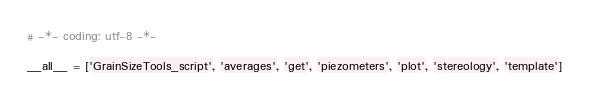<code> <loc_0><loc_0><loc_500><loc_500><_Python_># -*- coding: utf-8 -*-

__all__ = ['GrainSizeTools_script', 'averages', 'get', 'piezometers', 'plot', 'stereology', 'template']
</code> 